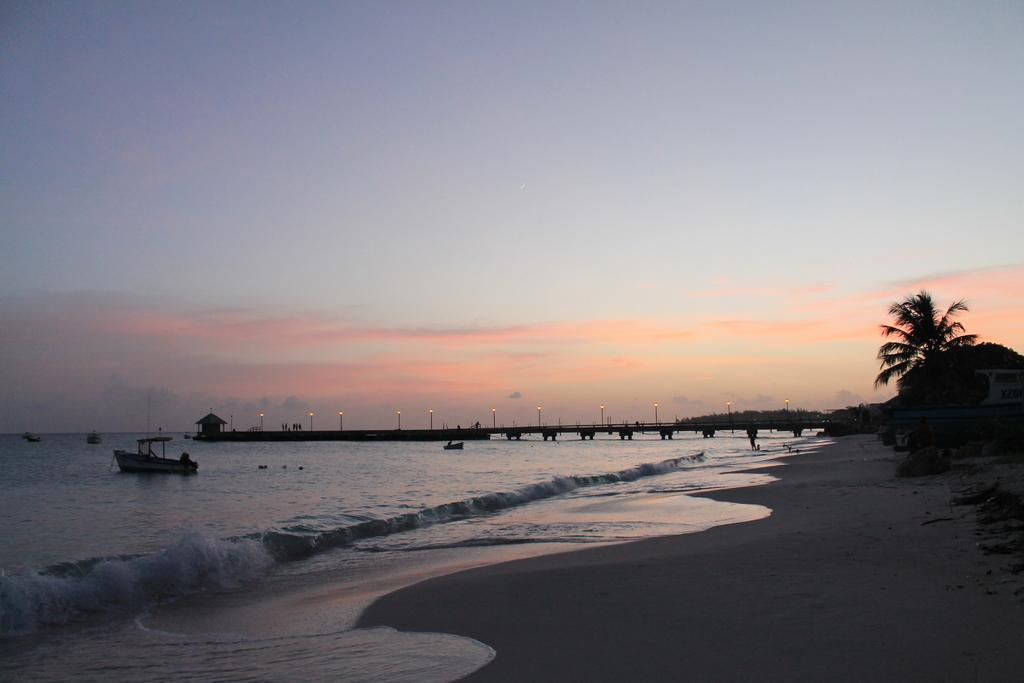What is in the water in the image? There are boats in the water in the image. What structure is visible above the water? A bridge is visible above the water in the image. What objects can be seen in the image besides the boats and bridge? There are poles and lights present in the image. Are there any living beings in the image? Yes, there are people in the image. What type of natural environment is visible in the image? Trees are visible in the image. What can be seen in the background of the image? The sky is visible in the background of the image. What type of thread is being used to hold the boats together in the image? There is no thread visible in the image, and the boats are not connected to each other. How are the people in the image saying good-bye to each other? There is no indication in the image that the people are saying good-bye to each other. 